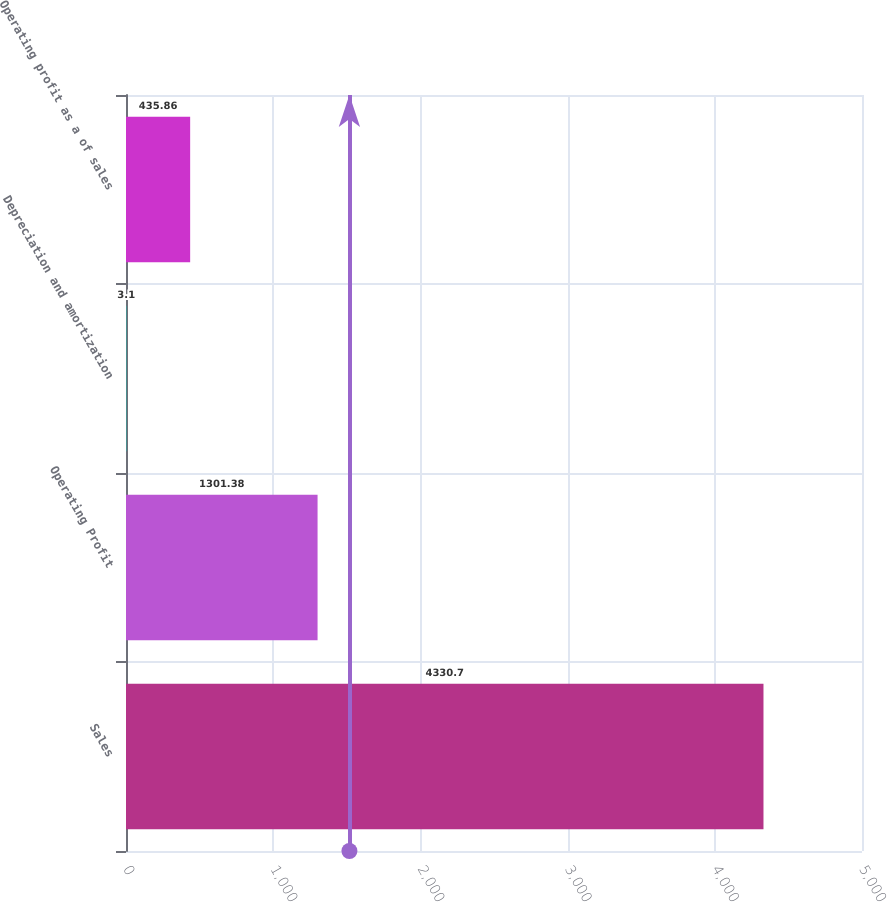<chart> <loc_0><loc_0><loc_500><loc_500><bar_chart><fcel>Sales<fcel>Operating Profit<fcel>Depreciation and amortization<fcel>Operating profit as a of sales<nl><fcel>4330.7<fcel>1301.38<fcel>3.1<fcel>435.86<nl></chart> 